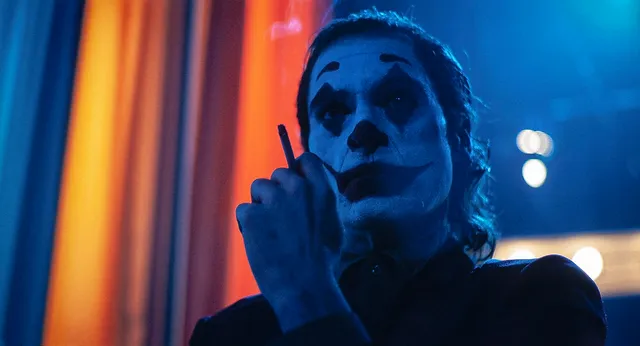Imagine if the Joker were holding something other than a cigarette, what would it be and how would it change the interpretation of this scene? If the Joker were holding a knife instead of a cigarette, the interpretation of the scene would shift dramatically towards a more overt and immediate sense of danger. The cigarette suggests a moment of introspection or calm before action, while a knife would imply an imminent and tangible threat, highlighting his violent tendencies and readiness to act. This change in prop would give the scene a more menacing and urgent tone, emphasizing the Joker's capacity for direct action and violence. What is the significance of the makeup design in this portrayal of the Joker? The makeup design in this portrayal of the Joker is significant for several reasons. The stark white base and exaggerated black features create a mask that simultaneously hides and reveals. It hides the true identity and emotions of the character, underscoring the Joker's role as an agent of chaos without personal vulnerability. At the sharegpt4v/same time, the sinister and theatrical appearance reveals his internal descent into madness and turmoil. The makeup serves as a visual metaphor for the duality within—an outwardly composed figure masking deep-seated chaos and insanity. It is a crucial element that enhances the character's eerie and unpredictable presence. If you could ask the Joker one question in this moment, what would it be? What do you truly hope to achieve through all the chaos you create? 